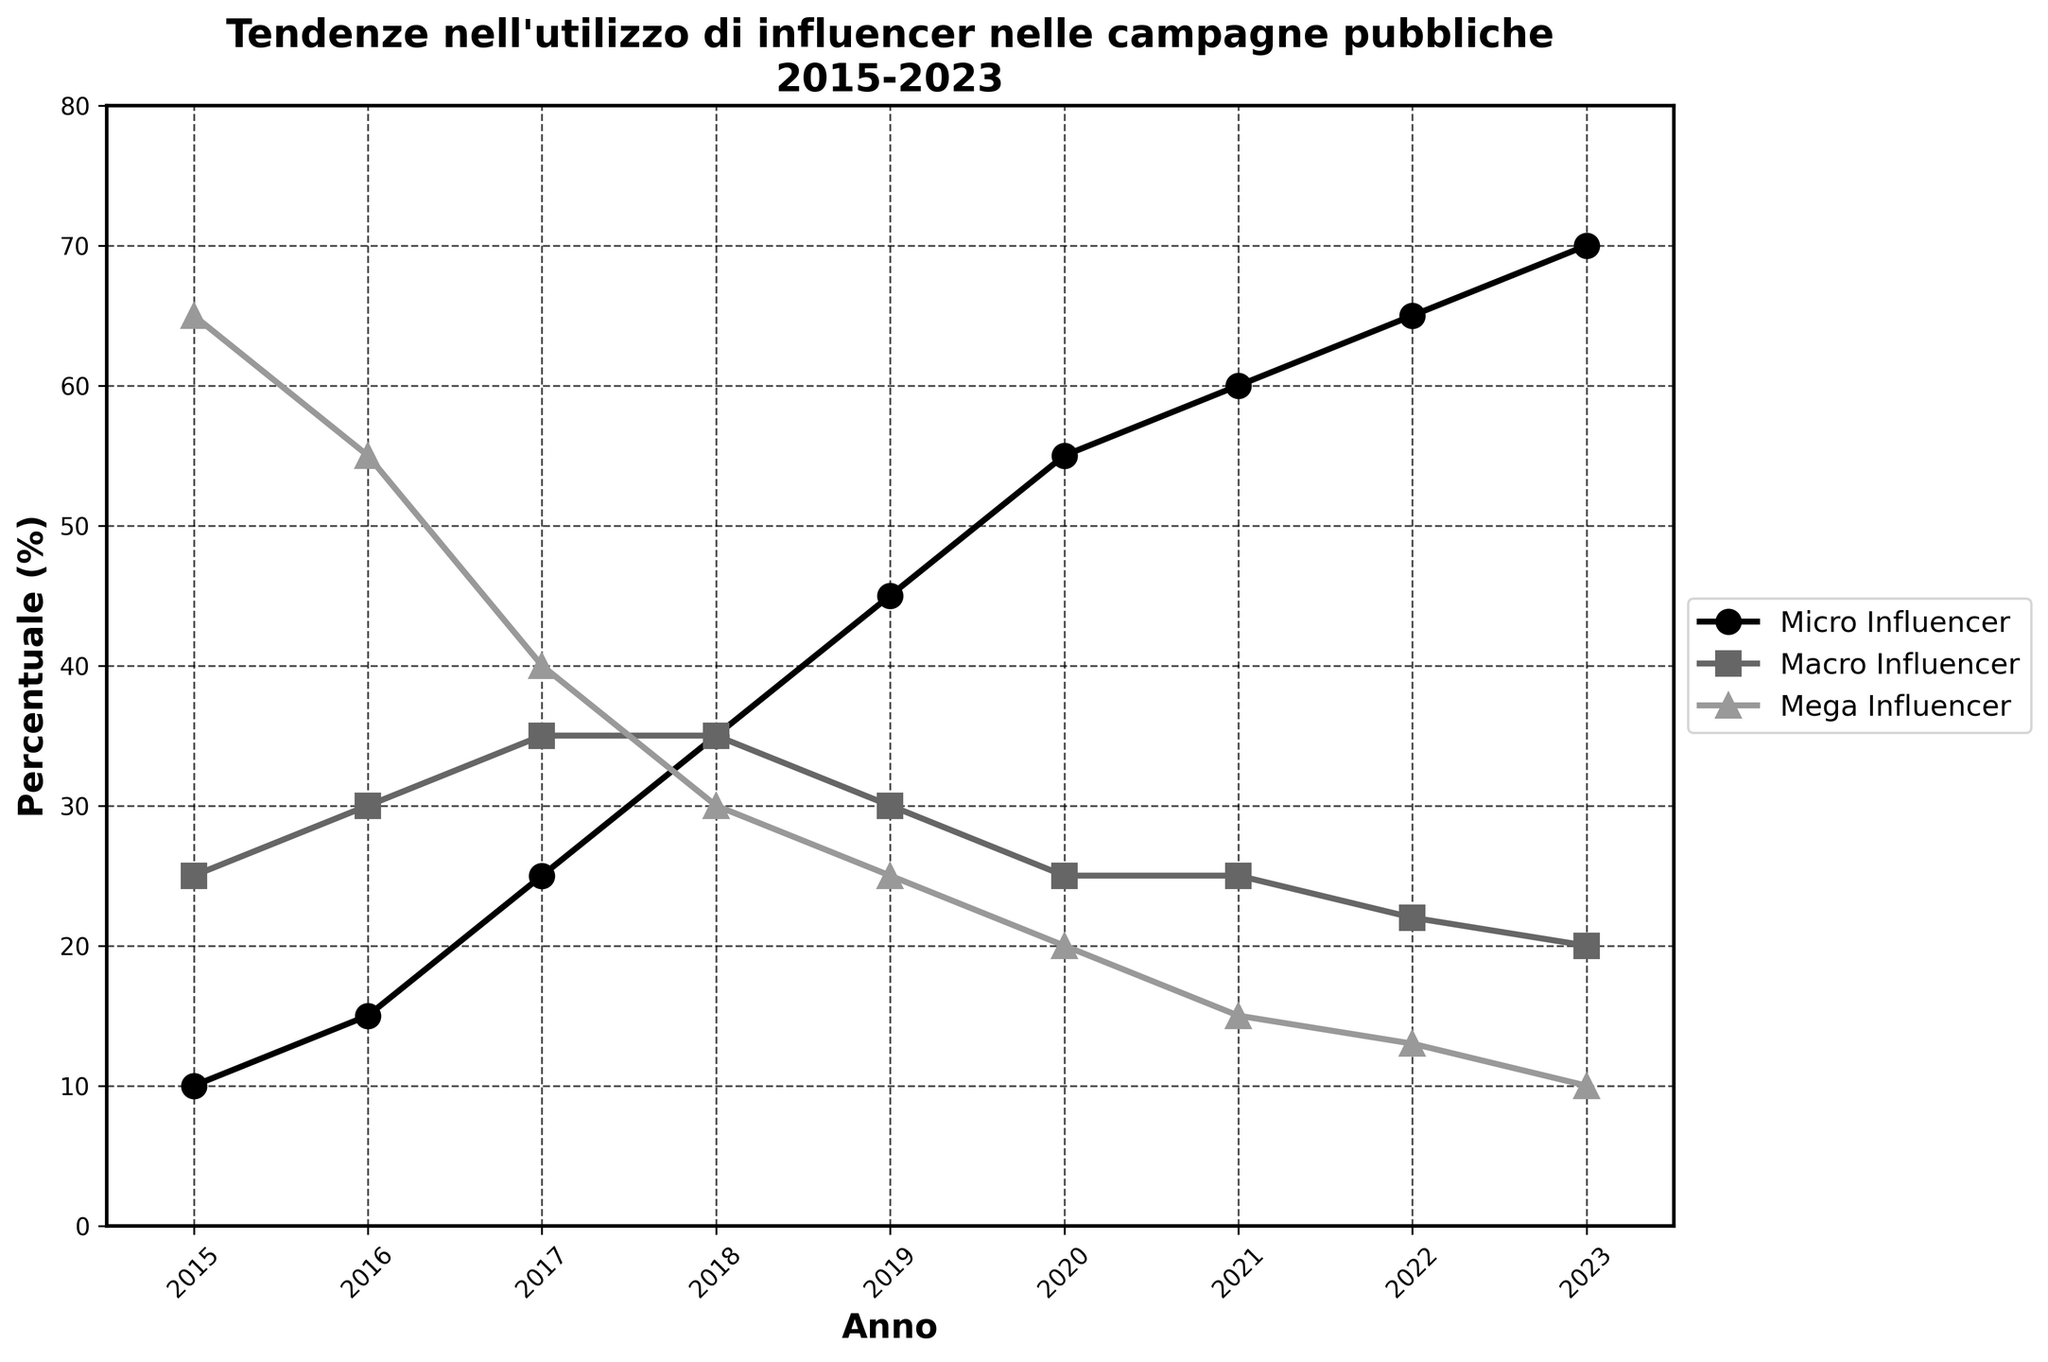When was the highest usage of Mega Influencers observed in public campaigns? The highest usage of Mega Influencers is identified by the peak point on the Mega Influencer line in the early years. Looking at the chart, Mega Influencers were used the most in 2015 with 65%.
Answer: 2015 How did the percentage usage of Micro Influencers change from 2015 to 2023? The percentage usage of Micro Influencers grew steadily throughout the years. Starting from 10% in 2015 to 70% in 2023. The change can be calculated as 70% - 10% = 60%.
Answer: Increased by 60% Which influencer type saw the most significant decline in usage from 2015 to 2023? By observing the overall trendlines, Mega Influencers show a consistent decrease from 65% in 2015 to 10% in 2023. This is a decline of 65% - 10% = 55%.
Answer: Mega Influencers During which year did the percentage usage of Macro and Mega Influencers become equal? The lines representing Macro and Mega Influencers intersect only once across the timeline. This point occurs in 2018 where both have a value of 35%.
Answer: 2018 What is the difference in the usage percentage between Macro and Micro Influencers in 2022? In 2022, the percentage of Micro Influencers is 65% and Macro Influencers is 22%. The difference is calculated as 65% - 22% = 43%.
Answer: 43% What trend is observed in the usage of Micro Influencers over the years? By examining the trendline for Micro Influencers, it is clear that there is a continuous upward trajectory from 10% in 2015 to 70% in 2023.
Answer: Increasing trend In which year did Micro Influencers surpass Mega Influencers in percentage usage? Looking at the intersection points, Micro Influencers cross above Mega Influencers around 2018 when Micro is at 35% and Mega is also at 30%.
Answer: 2017 How many times is the usage of Macro Influencers exactly 25%? The line representing Macro Influencers touches 25% at two points: 2020 and 2021.
Answer: Two times What is the average percentage usage of Mega Influencers from 2015 to 2019? The values for Mega Influencers from 2015 to 2019 are: 65%, 55%, 40%, 30%, 25%. Summing them up gives 215%. Dividing by 5 (number of years), the average is 215/5 = 43%.
Answer: 43% Which influencer type had the least variation in usage percentage over the years? By assessing the stability of the lines, Macro Influencers' usage remains relatively stable, fluctuating between 22% and 35%.
Answer: Macro Influencers 